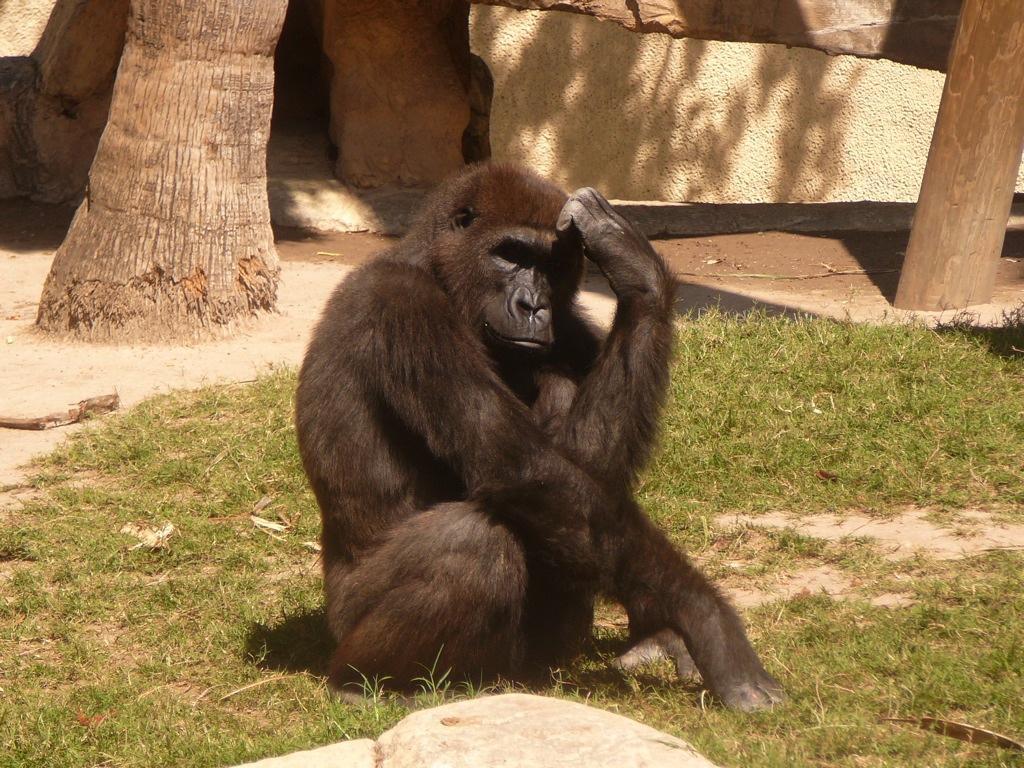In one or two sentences, can you explain what this image depicts? As we can see in the image there is grass, tree stem, rocks and black color chimpanzee. 